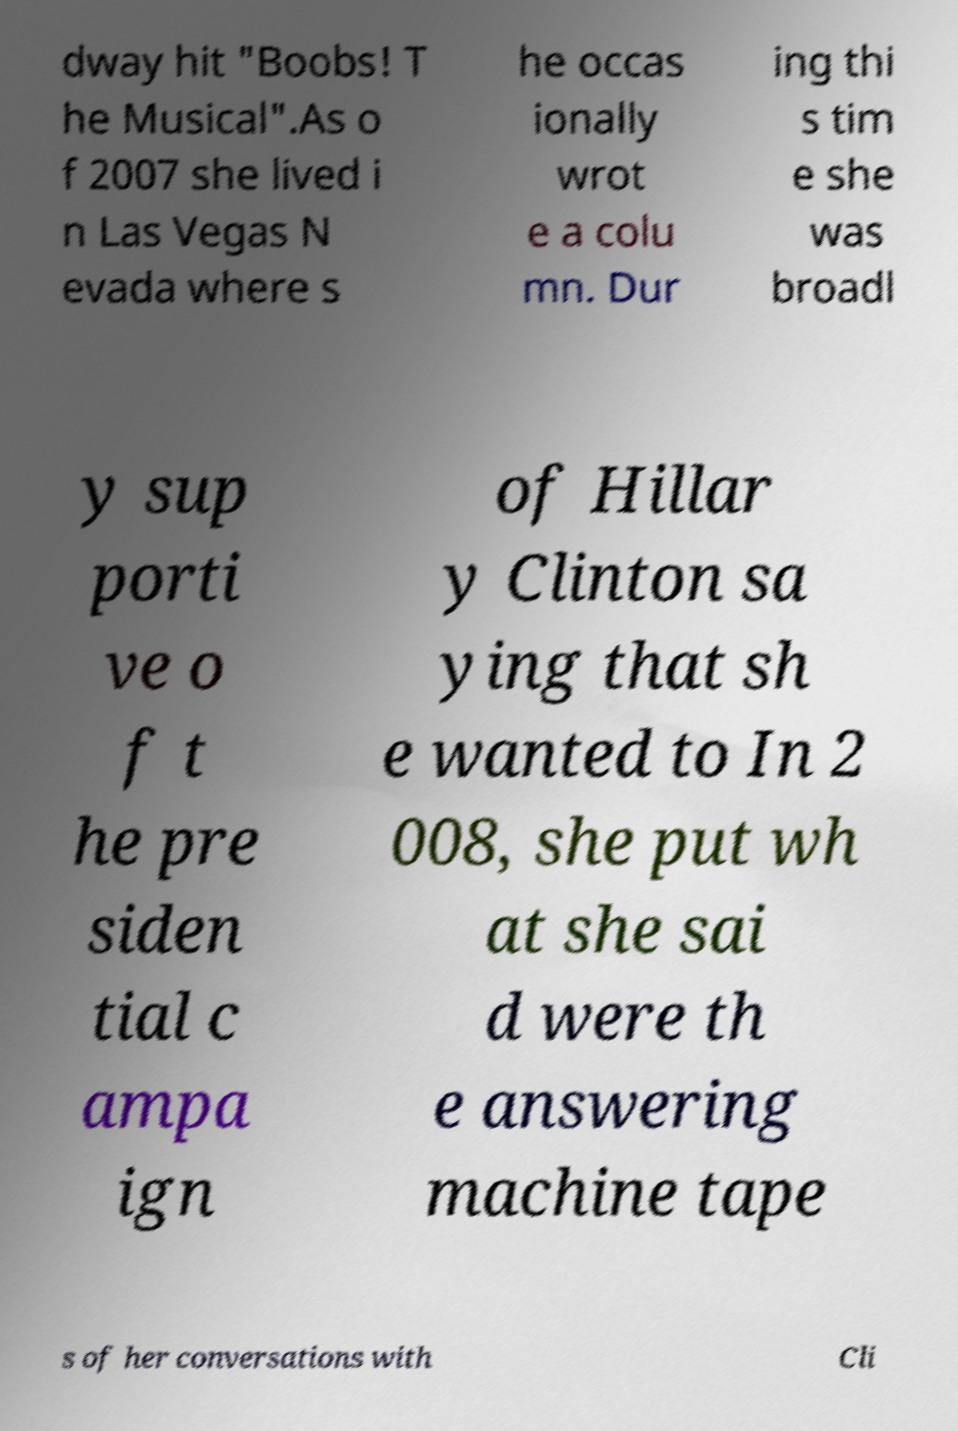Could you assist in decoding the text presented in this image and type it out clearly? dway hit "Boobs! T he Musical".As o f 2007 she lived i n Las Vegas N evada where s he occas ionally wrot e a colu mn. Dur ing thi s tim e she was broadl y sup porti ve o f t he pre siden tial c ampa ign of Hillar y Clinton sa ying that sh e wanted to In 2 008, she put wh at she sai d were th e answering machine tape s of her conversations with Cli 